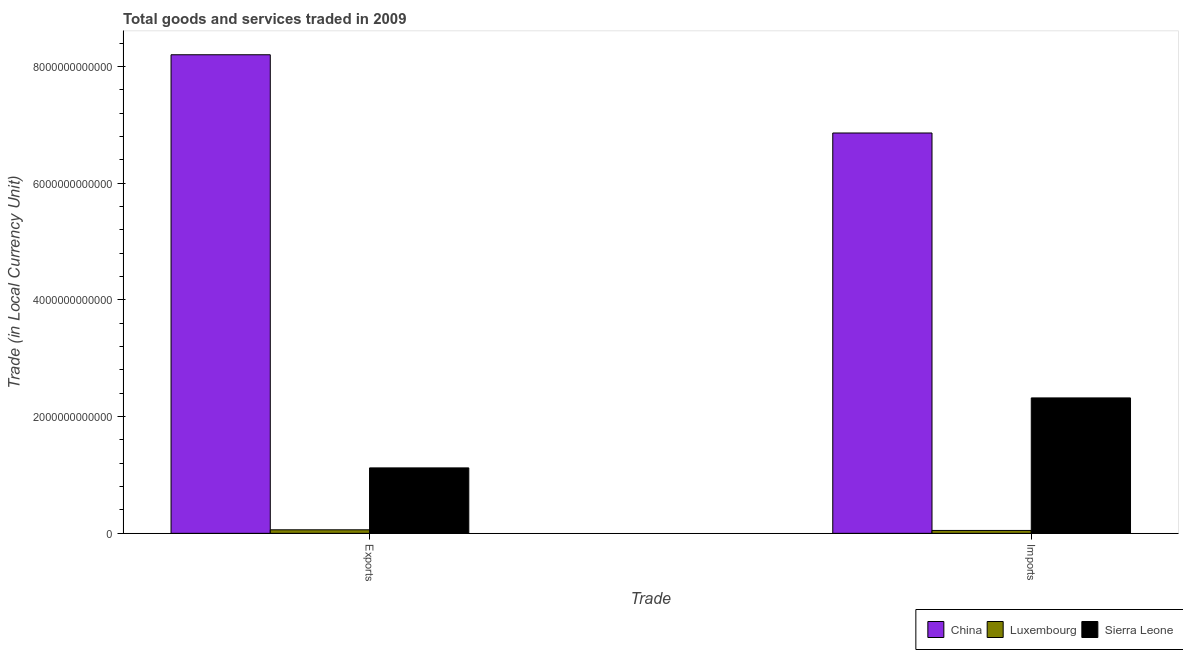How many different coloured bars are there?
Give a very brief answer. 3. Are the number of bars per tick equal to the number of legend labels?
Give a very brief answer. Yes. What is the label of the 2nd group of bars from the left?
Provide a short and direct response. Imports. What is the export of goods and services in China?
Provide a succinct answer. 8.20e+12. Across all countries, what is the maximum imports of goods and services?
Your answer should be compact. 6.86e+12. Across all countries, what is the minimum export of goods and services?
Your answer should be compact. 6.04e+1. In which country was the export of goods and services minimum?
Ensure brevity in your answer.  Luxembourg. What is the total export of goods and services in the graph?
Make the answer very short. 9.38e+12. What is the difference between the export of goods and services in Sierra Leone and that in Luxembourg?
Offer a very short reply. 1.06e+12. What is the difference between the imports of goods and services in Luxembourg and the export of goods and services in China?
Provide a short and direct response. -8.15e+12. What is the average export of goods and services per country?
Keep it short and to the point. 3.13e+12. What is the difference between the imports of goods and services and export of goods and services in China?
Offer a terse response. -1.34e+12. What is the ratio of the imports of goods and services in Sierra Leone to that in China?
Offer a terse response. 0.34. Is the imports of goods and services in Luxembourg less than that in China?
Provide a succinct answer. Yes. What does the 2nd bar from the left in Exports represents?
Offer a terse response. Luxembourg. What does the 2nd bar from the right in Exports represents?
Your answer should be compact. Luxembourg. How many bars are there?
Your answer should be very brief. 6. Are all the bars in the graph horizontal?
Ensure brevity in your answer.  No. How many countries are there in the graph?
Make the answer very short. 3. What is the difference between two consecutive major ticks on the Y-axis?
Give a very brief answer. 2.00e+12. How many legend labels are there?
Offer a very short reply. 3. How are the legend labels stacked?
Your answer should be very brief. Horizontal. What is the title of the graph?
Keep it short and to the point. Total goods and services traded in 2009. What is the label or title of the X-axis?
Your response must be concise. Trade. What is the label or title of the Y-axis?
Your response must be concise. Trade (in Local Currency Unit). What is the Trade (in Local Currency Unit) of China in Exports?
Offer a very short reply. 8.20e+12. What is the Trade (in Local Currency Unit) in Luxembourg in Exports?
Ensure brevity in your answer.  6.04e+1. What is the Trade (in Local Currency Unit) of Sierra Leone in Exports?
Your answer should be compact. 1.12e+12. What is the Trade (in Local Currency Unit) in China in Imports?
Provide a succinct answer. 6.86e+12. What is the Trade (in Local Currency Unit) of Luxembourg in Imports?
Offer a very short reply. 4.95e+1. What is the Trade (in Local Currency Unit) in Sierra Leone in Imports?
Make the answer very short. 2.32e+12. Across all Trade, what is the maximum Trade (in Local Currency Unit) of China?
Make the answer very short. 8.20e+12. Across all Trade, what is the maximum Trade (in Local Currency Unit) of Luxembourg?
Ensure brevity in your answer.  6.04e+1. Across all Trade, what is the maximum Trade (in Local Currency Unit) in Sierra Leone?
Offer a terse response. 2.32e+12. Across all Trade, what is the minimum Trade (in Local Currency Unit) in China?
Offer a terse response. 6.86e+12. Across all Trade, what is the minimum Trade (in Local Currency Unit) of Luxembourg?
Your response must be concise. 4.95e+1. Across all Trade, what is the minimum Trade (in Local Currency Unit) in Sierra Leone?
Give a very brief answer. 1.12e+12. What is the total Trade (in Local Currency Unit) of China in the graph?
Your answer should be very brief. 1.51e+13. What is the total Trade (in Local Currency Unit) of Luxembourg in the graph?
Keep it short and to the point. 1.10e+11. What is the total Trade (in Local Currency Unit) of Sierra Leone in the graph?
Make the answer very short. 3.44e+12. What is the difference between the Trade (in Local Currency Unit) of China in Exports and that in Imports?
Your response must be concise. 1.34e+12. What is the difference between the Trade (in Local Currency Unit) of Luxembourg in Exports and that in Imports?
Give a very brief answer. 1.09e+1. What is the difference between the Trade (in Local Currency Unit) in Sierra Leone in Exports and that in Imports?
Keep it short and to the point. -1.20e+12. What is the difference between the Trade (in Local Currency Unit) of China in Exports and the Trade (in Local Currency Unit) of Luxembourg in Imports?
Keep it short and to the point. 8.15e+12. What is the difference between the Trade (in Local Currency Unit) in China in Exports and the Trade (in Local Currency Unit) in Sierra Leone in Imports?
Provide a short and direct response. 5.88e+12. What is the difference between the Trade (in Local Currency Unit) of Luxembourg in Exports and the Trade (in Local Currency Unit) of Sierra Leone in Imports?
Give a very brief answer. -2.26e+12. What is the average Trade (in Local Currency Unit) of China per Trade?
Provide a short and direct response. 7.53e+12. What is the average Trade (in Local Currency Unit) of Luxembourg per Trade?
Provide a short and direct response. 5.50e+1. What is the average Trade (in Local Currency Unit) of Sierra Leone per Trade?
Your answer should be compact. 1.72e+12. What is the difference between the Trade (in Local Currency Unit) in China and Trade (in Local Currency Unit) in Luxembourg in Exports?
Your answer should be very brief. 8.14e+12. What is the difference between the Trade (in Local Currency Unit) of China and Trade (in Local Currency Unit) of Sierra Leone in Exports?
Offer a terse response. 7.08e+12. What is the difference between the Trade (in Local Currency Unit) of Luxembourg and Trade (in Local Currency Unit) of Sierra Leone in Exports?
Provide a short and direct response. -1.06e+12. What is the difference between the Trade (in Local Currency Unit) of China and Trade (in Local Currency Unit) of Luxembourg in Imports?
Provide a succinct answer. 6.81e+12. What is the difference between the Trade (in Local Currency Unit) in China and Trade (in Local Currency Unit) in Sierra Leone in Imports?
Keep it short and to the point. 4.54e+12. What is the difference between the Trade (in Local Currency Unit) in Luxembourg and Trade (in Local Currency Unit) in Sierra Leone in Imports?
Offer a very short reply. -2.27e+12. What is the ratio of the Trade (in Local Currency Unit) of China in Exports to that in Imports?
Offer a terse response. 1.2. What is the ratio of the Trade (in Local Currency Unit) of Luxembourg in Exports to that in Imports?
Offer a very short reply. 1.22. What is the ratio of the Trade (in Local Currency Unit) of Sierra Leone in Exports to that in Imports?
Offer a very short reply. 0.48. What is the difference between the highest and the second highest Trade (in Local Currency Unit) of China?
Make the answer very short. 1.34e+12. What is the difference between the highest and the second highest Trade (in Local Currency Unit) in Luxembourg?
Your answer should be very brief. 1.09e+1. What is the difference between the highest and the second highest Trade (in Local Currency Unit) of Sierra Leone?
Your response must be concise. 1.20e+12. What is the difference between the highest and the lowest Trade (in Local Currency Unit) in China?
Ensure brevity in your answer.  1.34e+12. What is the difference between the highest and the lowest Trade (in Local Currency Unit) of Luxembourg?
Give a very brief answer. 1.09e+1. What is the difference between the highest and the lowest Trade (in Local Currency Unit) in Sierra Leone?
Give a very brief answer. 1.20e+12. 